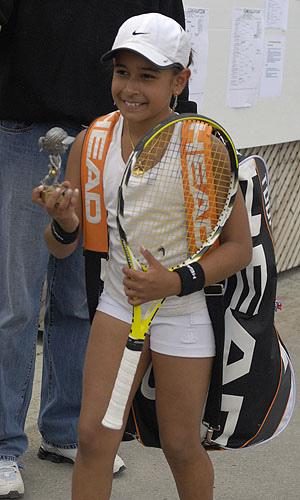What is the girl doing?
Concise answer only. Smiling. Is she wearing a hat?
Quick response, please. Yes. What sport is this?
Write a very short answer. Tennis. Did this girl win?
Short answer required. Yes. 